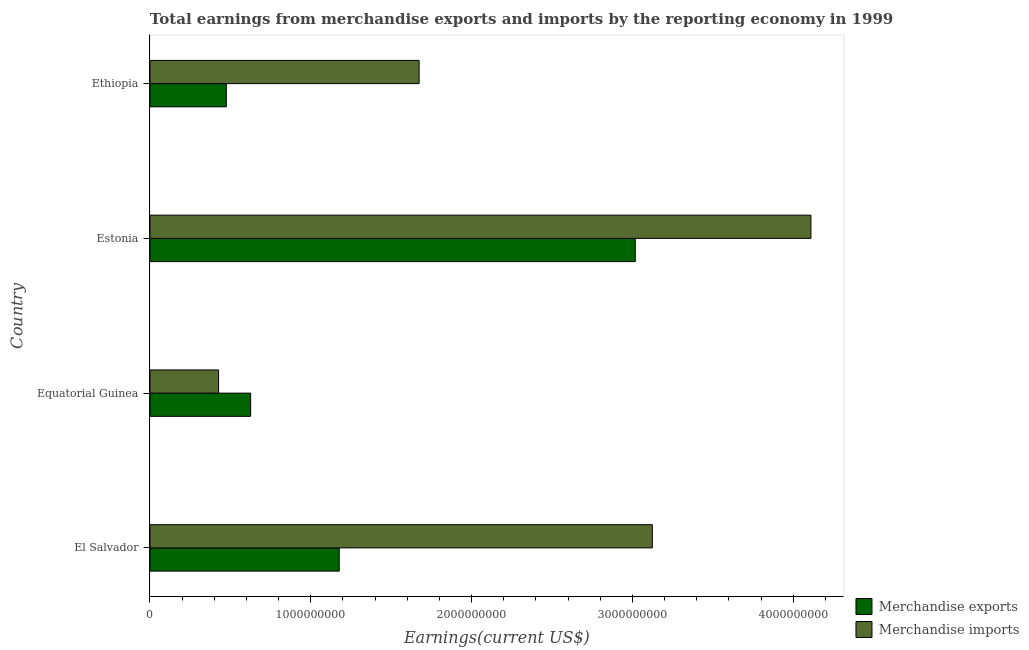How many groups of bars are there?
Your answer should be very brief. 4. Are the number of bars per tick equal to the number of legend labels?
Offer a very short reply. Yes. How many bars are there on the 2nd tick from the bottom?
Offer a very short reply. 2. What is the label of the 4th group of bars from the top?
Offer a terse response. El Salvador. What is the earnings from merchandise imports in Equatorial Guinea?
Your answer should be very brief. 4.27e+08. Across all countries, what is the maximum earnings from merchandise exports?
Offer a terse response. 3.02e+09. Across all countries, what is the minimum earnings from merchandise imports?
Make the answer very short. 4.27e+08. In which country was the earnings from merchandise imports maximum?
Offer a terse response. Estonia. In which country was the earnings from merchandise imports minimum?
Make the answer very short. Equatorial Guinea. What is the total earnings from merchandise imports in the graph?
Provide a succinct answer. 9.33e+09. What is the difference between the earnings from merchandise exports in El Salvador and that in Estonia?
Make the answer very short. -1.84e+09. What is the difference between the earnings from merchandise exports in Estonia and the earnings from merchandise imports in Equatorial Guinea?
Make the answer very short. 2.59e+09. What is the average earnings from merchandise exports per country?
Provide a short and direct response. 1.32e+09. What is the difference between the earnings from merchandise imports and earnings from merchandise exports in Estonia?
Provide a short and direct response. 1.09e+09. What is the ratio of the earnings from merchandise exports in El Salvador to that in Estonia?
Keep it short and to the point. 0.39. Is the earnings from merchandise exports in Equatorial Guinea less than that in Ethiopia?
Make the answer very short. No. Is the difference between the earnings from merchandise imports in El Salvador and Ethiopia greater than the difference between the earnings from merchandise exports in El Salvador and Ethiopia?
Your answer should be compact. Yes. What is the difference between the highest and the second highest earnings from merchandise imports?
Offer a very short reply. 9.86e+08. What is the difference between the highest and the lowest earnings from merchandise imports?
Offer a terse response. 3.68e+09. In how many countries, is the earnings from merchandise exports greater than the average earnings from merchandise exports taken over all countries?
Make the answer very short. 1. Is the sum of the earnings from merchandise exports in Equatorial Guinea and Ethiopia greater than the maximum earnings from merchandise imports across all countries?
Your answer should be very brief. No. What does the 1st bar from the top in Equatorial Guinea represents?
Your response must be concise. Merchandise imports. What does the 1st bar from the bottom in Equatorial Guinea represents?
Keep it short and to the point. Merchandise exports. How many bars are there?
Offer a very short reply. 8. How many countries are there in the graph?
Provide a succinct answer. 4. Are the values on the major ticks of X-axis written in scientific E-notation?
Offer a terse response. No. Does the graph contain grids?
Offer a very short reply. No. What is the title of the graph?
Make the answer very short. Total earnings from merchandise exports and imports by the reporting economy in 1999. Does "Total Population" appear as one of the legend labels in the graph?
Ensure brevity in your answer.  No. What is the label or title of the X-axis?
Offer a terse response. Earnings(current US$). What is the label or title of the Y-axis?
Offer a terse response. Country. What is the Earnings(current US$) in Merchandise exports in El Salvador?
Give a very brief answer. 1.18e+09. What is the Earnings(current US$) of Merchandise imports in El Salvador?
Provide a succinct answer. 3.12e+09. What is the Earnings(current US$) in Merchandise exports in Equatorial Guinea?
Your answer should be very brief. 6.26e+08. What is the Earnings(current US$) in Merchandise imports in Equatorial Guinea?
Offer a terse response. 4.27e+08. What is the Earnings(current US$) in Merchandise exports in Estonia?
Provide a short and direct response. 3.02e+09. What is the Earnings(current US$) in Merchandise imports in Estonia?
Offer a terse response. 4.11e+09. What is the Earnings(current US$) of Merchandise exports in Ethiopia?
Your answer should be compact. 4.75e+08. What is the Earnings(current US$) of Merchandise imports in Ethiopia?
Ensure brevity in your answer.  1.67e+09. Across all countries, what is the maximum Earnings(current US$) of Merchandise exports?
Offer a terse response. 3.02e+09. Across all countries, what is the maximum Earnings(current US$) of Merchandise imports?
Keep it short and to the point. 4.11e+09. Across all countries, what is the minimum Earnings(current US$) of Merchandise exports?
Provide a succinct answer. 4.75e+08. Across all countries, what is the minimum Earnings(current US$) in Merchandise imports?
Make the answer very short. 4.27e+08. What is the total Earnings(current US$) in Merchandise exports in the graph?
Provide a short and direct response. 5.29e+09. What is the total Earnings(current US$) in Merchandise imports in the graph?
Give a very brief answer. 9.33e+09. What is the difference between the Earnings(current US$) in Merchandise exports in El Salvador and that in Equatorial Guinea?
Provide a short and direct response. 5.51e+08. What is the difference between the Earnings(current US$) of Merchandise imports in El Salvador and that in Equatorial Guinea?
Provide a short and direct response. 2.70e+09. What is the difference between the Earnings(current US$) in Merchandise exports in El Salvador and that in Estonia?
Your response must be concise. -1.84e+09. What is the difference between the Earnings(current US$) in Merchandise imports in El Salvador and that in Estonia?
Provide a succinct answer. -9.86e+08. What is the difference between the Earnings(current US$) of Merchandise exports in El Salvador and that in Ethiopia?
Offer a terse response. 7.02e+08. What is the difference between the Earnings(current US$) in Merchandise imports in El Salvador and that in Ethiopia?
Offer a terse response. 1.45e+09. What is the difference between the Earnings(current US$) in Merchandise exports in Equatorial Guinea and that in Estonia?
Your response must be concise. -2.39e+09. What is the difference between the Earnings(current US$) in Merchandise imports in Equatorial Guinea and that in Estonia?
Keep it short and to the point. -3.68e+09. What is the difference between the Earnings(current US$) of Merchandise exports in Equatorial Guinea and that in Ethiopia?
Provide a succinct answer. 1.51e+08. What is the difference between the Earnings(current US$) of Merchandise imports in Equatorial Guinea and that in Ethiopia?
Make the answer very short. -1.25e+09. What is the difference between the Earnings(current US$) in Merchandise exports in Estonia and that in Ethiopia?
Your response must be concise. 2.54e+09. What is the difference between the Earnings(current US$) in Merchandise imports in Estonia and that in Ethiopia?
Make the answer very short. 2.44e+09. What is the difference between the Earnings(current US$) of Merchandise exports in El Salvador and the Earnings(current US$) of Merchandise imports in Equatorial Guinea?
Your answer should be compact. 7.50e+08. What is the difference between the Earnings(current US$) of Merchandise exports in El Salvador and the Earnings(current US$) of Merchandise imports in Estonia?
Give a very brief answer. -2.93e+09. What is the difference between the Earnings(current US$) of Merchandise exports in El Salvador and the Earnings(current US$) of Merchandise imports in Ethiopia?
Your answer should be very brief. -4.97e+08. What is the difference between the Earnings(current US$) of Merchandise exports in Equatorial Guinea and the Earnings(current US$) of Merchandise imports in Estonia?
Your response must be concise. -3.48e+09. What is the difference between the Earnings(current US$) of Merchandise exports in Equatorial Guinea and the Earnings(current US$) of Merchandise imports in Ethiopia?
Keep it short and to the point. -1.05e+09. What is the difference between the Earnings(current US$) of Merchandise exports in Estonia and the Earnings(current US$) of Merchandise imports in Ethiopia?
Your answer should be very brief. 1.34e+09. What is the average Earnings(current US$) in Merchandise exports per country?
Give a very brief answer. 1.32e+09. What is the average Earnings(current US$) of Merchandise imports per country?
Your response must be concise. 2.33e+09. What is the difference between the Earnings(current US$) of Merchandise exports and Earnings(current US$) of Merchandise imports in El Salvador?
Your answer should be very brief. -1.95e+09. What is the difference between the Earnings(current US$) in Merchandise exports and Earnings(current US$) in Merchandise imports in Equatorial Guinea?
Offer a very short reply. 1.99e+08. What is the difference between the Earnings(current US$) of Merchandise exports and Earnings(current US$) of Merchandise imports in Estonia?
Provide a short and direct response. -1.09e+09. What is the difference between the Earnings(current US$) in Merchandise exports and Earnings(current US$) in Merchandise imports in Ethiopia?
Your answer should be compact. -1.20e+09. What is the ratio of the Earnings(current US$) of Merchandise exports in El Salvador to that in Equatorial Guinea?
Offer a very short reply. 1.88. What is the ratio of the Earnings(current US$) of Merchandise imports in El Salvador to that in Equatorial Guinea?
Provide a succinct answer. 7.32. What is the ratio of the Earnings(current US$) of Merchandise exports in El Salvador to that in Estonia?
Keep it short and to the point. 0.39. What is the ratio of the Earnings(current US$) of Merchandise imports in El Salvador to that in Estonia?
Provide a short and direct response. 0.76. What is the ratio of the Earnings(current US$) of Merchandise exports in El Salvador to that in Ethiopia?
Offer a terse response. 2.48. What is the ratio of the Earnings(current US$) of Merchandise imports in El Salvador to that in Ethiopia?
Offer a very short reply. 1.87. What is the ratio of the Earnings(current US$) in Merchandise exports in Equatorial Guinea to that in Estonia?
Provide a short and direct response. 0.21. What is the ratio of the Earnings(current US$) in Merchandise imports in Equatorial Guinea to that in Estonia?
Ensure brevity in your answer.  0.1. What is the ratio of the Earnings(current US$) of Merchandise exports in Equatorial Guinea to that in Ethiopia?
Your answer should be compact. 1.32. What is the ratio of the Earnings(current US$) of Merchandise imports in Equatorial Guinea to that in Ethiopia?
Offer a terse response. 0.25. What is the ratio of the Earnings(current US$) of Merchandise exports in Estonia to that in Ethiopia?
Your answer should be compact. 6.36. What is the ratio of the Earnings(current US$) in Merchandise imports in Estonia to that in Ethiopia?
Offer a terse response. 2.46. What is the difference between the highest and the second highest Earnings(current US$) of Merchandise exports?
Provide a short and direct response. 1.84e+09. What is the difference between the highest and the second highest Earnings(current US$) in Merchandise imports?
Your answer should be very brief. 9.86e+08. What is the difference between the highest and the lowest Earnings(current US$) in Merchandise exports?
Keep it short and to the point. 2.54e+09. What is the difference between the highest and the lowest Earnings(current US$) in Merchandise imports?
Provide a short and direct response. 3.68e+09. 